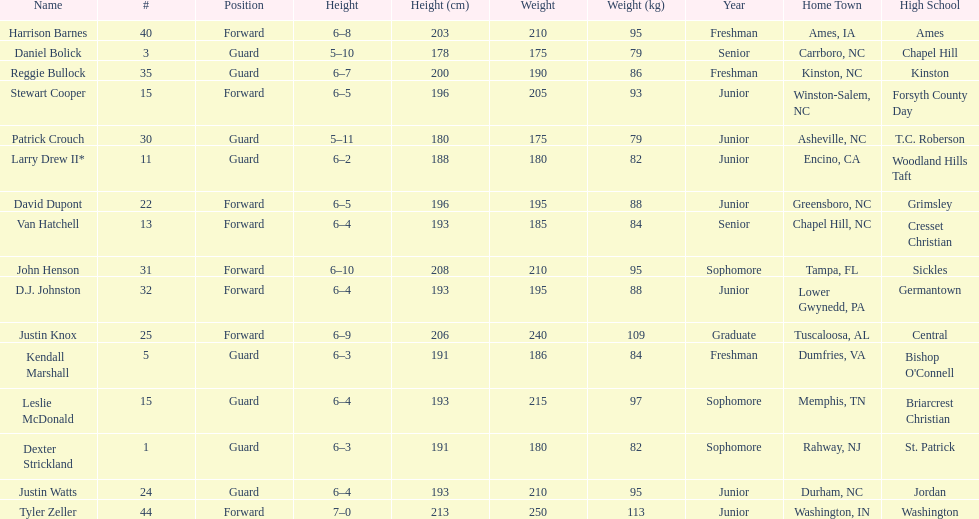How many players are not a junior? 9. I'm looking to parse the entire table for insights. Could you assist me with that? {'header': ['Name', '#', 'Position', 'Height', 'Height (cm)', 'Weight', 'Weight (kg)', 'Year', 'Home Town', 'High School'], 'rows': [['Harrison Barnes', '40', 'Forward', '6–8', '203', '210', '95', 'Freshman', 'Ames, IA', 'Ames'], ['Daniel Bolick', '3', 'Guard', '5–10', '178', '175', '79', 'Senior', 'Carrboro, NC', 'Chapel Hill'], ['Reggie Bullock', '35', 'Guard', '6–7', '200', '190', '86', 'Freshman', 'Kinston, NC', 'Kinston'], ['Stewart Cooper', '15', 'Forward', '6–5', '196', '205', '93', 'Junior', 'Winston-Salem, NC', 'Forsyth County Day'], ['Patrick Crouch', '30', 'Guard', '5–11', '180', '175', '79', 'Junior', 'Asheville, NC', 'T.C. Roberson'], ['Larry Drew II*', '11', 'Guard', '6–2', '188', '180', '82', 'Junior', 'Encino, CA', 'Woodland Hills Taft'], ['David Dupont', '22', 'Forward', '6–5', '196', '195', '88', 'Junior', 'Greensboro, NC', 'Grimsley'], ['Van Hatchell', '13', 'Forward', '6–4', '193', '185', '84', 'Senior', 'Chapel Hill, NC', 'Cresset Christian'], ['John Henson', '31', 'Forward', '6–10', '208', '210', '95', 'Sophomore', 'Tampa, FL', 'Sickles'], ['D.J. Johnston', '32', 'Forward', '6–4', '193', '195', '88', 'Junior', 'Lower Gwynedd, PA', 'Germantown'], ['Justin Knox', '25', 'Forward', '6–9', '206', '240', '109', 'Graduate', 'Tuscaloosa, AL', 'Central'], ['Kendall Marshall', '5', 'Guard', '6–3', '191', '186', '84', 'Freshman', 'Dumfries, VA', "Bishop O'Connell"], ['Leslie McDonald', '15', 'Guard', '6–4', '193', '215', '97', 'Sophomore', 'Memphis, TN', 'Briarcrest Christian'], ['Dexter Strickland', '1', 'Guard', '6–3', '191', '180', '82', 'Sophomore', 'Rahway, NJ', 'St. Patrick'], ['Justin Watts', '24', 'Guard', '6–4', '193', '210', '95', 'Junior', 'Durham, NC', 'Jordan'], ['Tyler Zeller', '44', 'Forward', '7–0', '213', '250', '113', 'Junior', 'Washington, IN', 'Washington']]} 